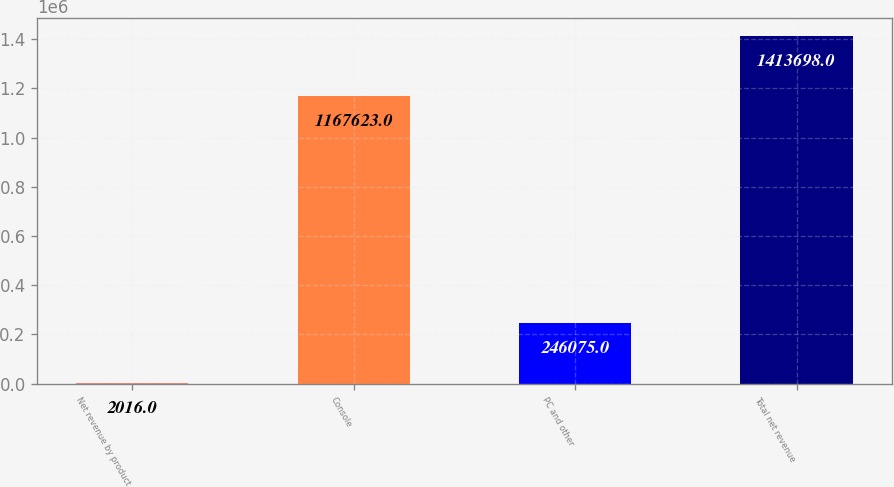<chart> <loc_0><loc_0><loc_500><loc_500><bar_chart><fcel>Net revenue by product<fcel>Console<fcel>PC and other<fcel>Total net revenue<nl><fcel>2016<fcel>1.16762e+06<fcel>246075<fcel>1.4137e+06<nl></chart> 